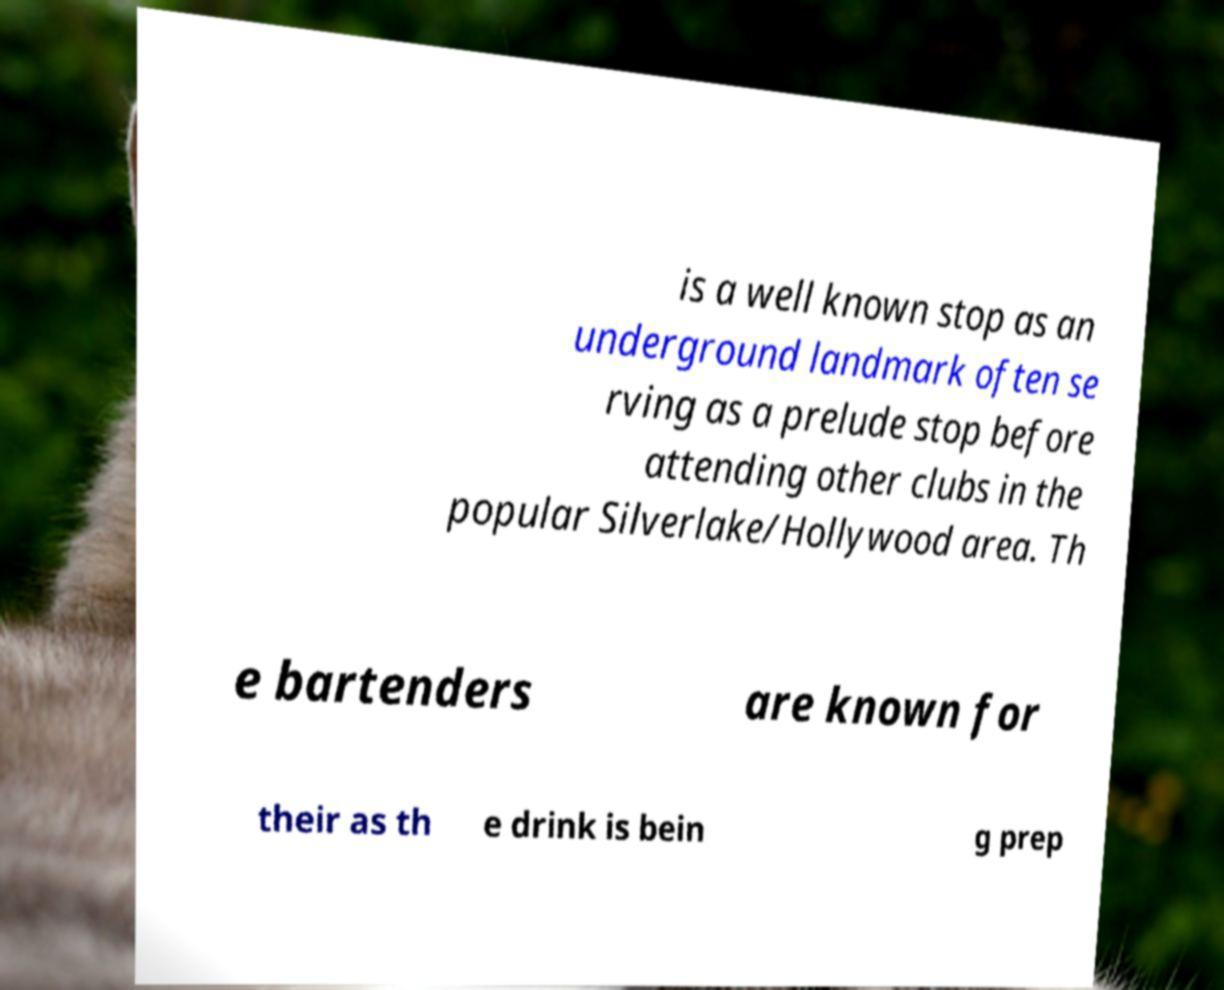Could you extract and type out the text from this image? is a well known stop as an underground landmark often se rving as a prelude stop before attending other clubs in the popular Silverlake/Hollywood area. Th e bartenders are known for their as th e drink is bein g prep 